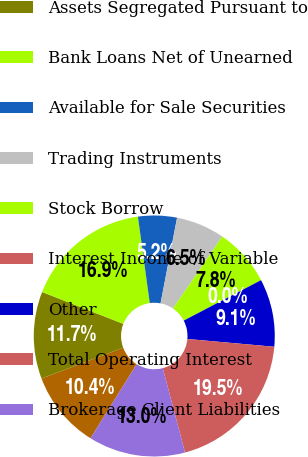<chart> <loc_0><loc_0><loc_500><loc_500><pie_chart><fcel>Margin Balances<fcel>Assets Segregated Pursuant to<fcel>Bank Loans Net of Unearned<fcel>Available for Sale Securities<fcel>Trading Instruments<fcel>Stock Borrow<fcel>Interest Income of Variable<fcel>Other<fcel>Total Operating Interest<fcel>Brokerage Client Liabilities<nl><fcel>10.39%<fcel>11.69%<fcel>16.88%<fcel>5.2%<fcel>6.5%<fcel>7.79%<fcel>0.01%<fcel>9.09%<fcel>19.47%<fcel>12.98%<nl></chart> 